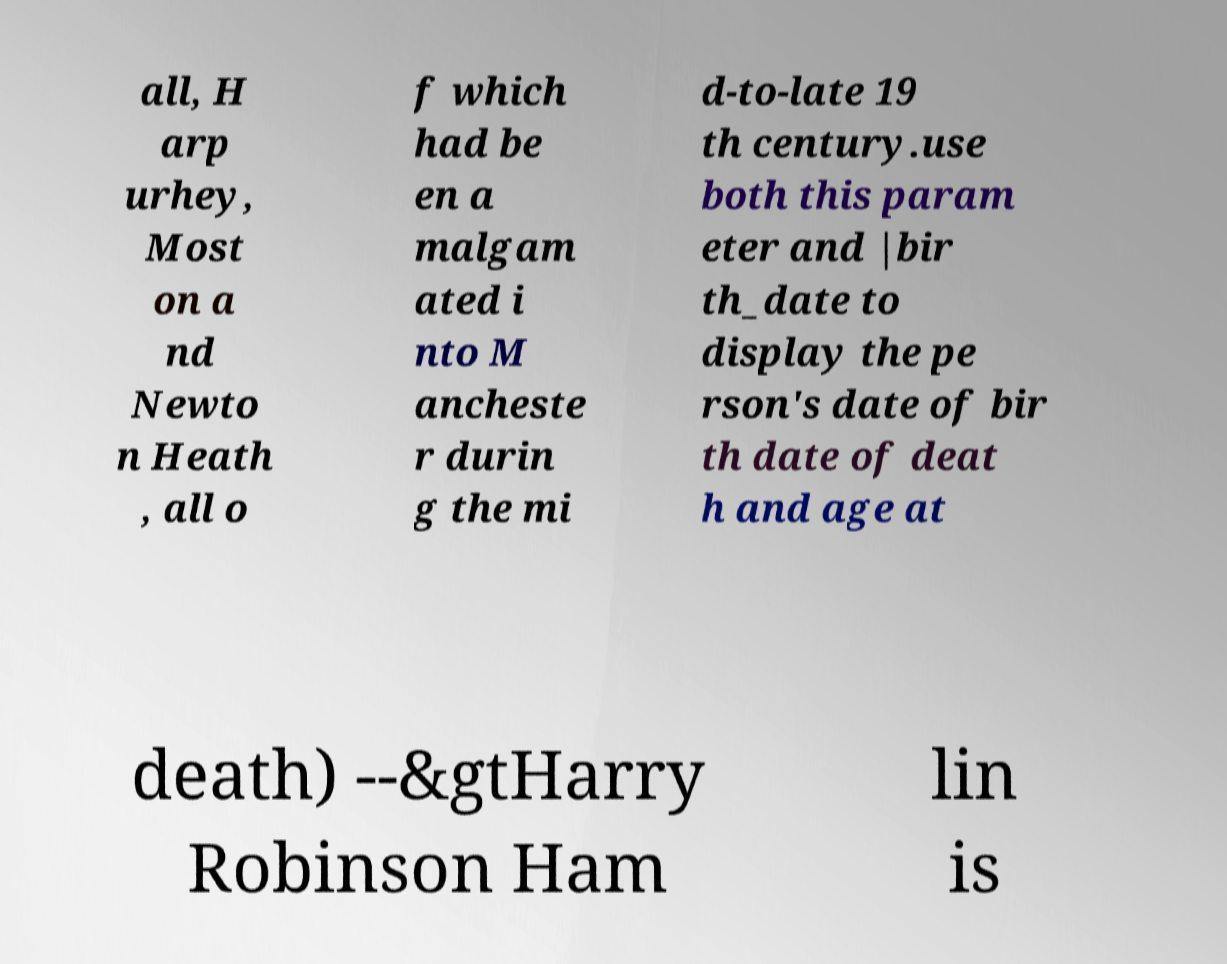Could you assist in decoding the text presented in this image and type it out clearly? all, H arp urhey, Most on a nd Newto n Heath , all o f which had be en a malgam ated i nto M ancheste r durin g the mi d-to-late 19 th century.use both this param eter and |bir th_date to display the pe rson's date of bir th date of deat h and age at death) --&gtHarry Robinson Ham lin is 